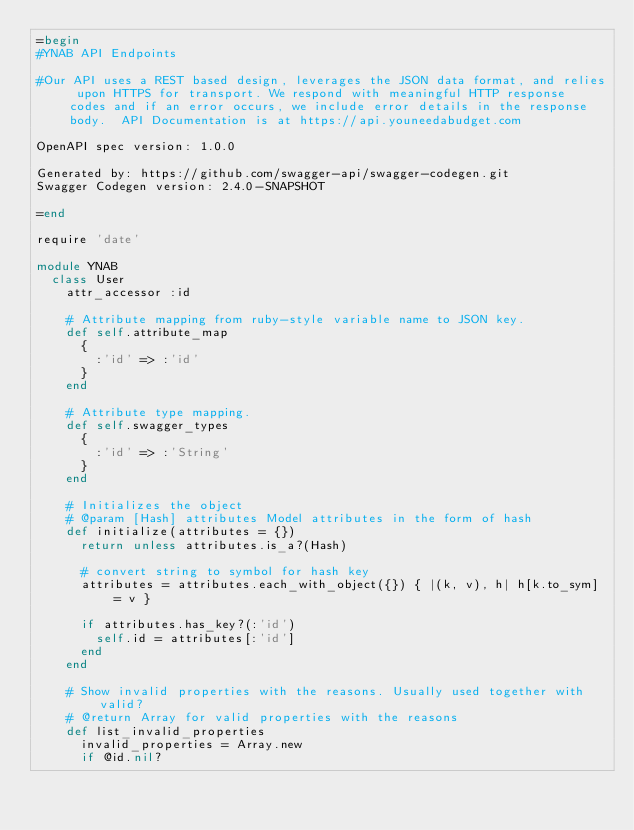Convert code to text. <code><loc_0><loc_0><loc_500><loc_500><_Ruby_>=begin
#YNAB API Endpoints

#Our API uses a REST based design, leverages the JSON data format, and relies upon HTTPS for transport. We respond with meaningful HTTP response codes and if an error occurs, we include error details in the response body.  API Documentation is at https://api.youneedabudget.com

OpenAPI spec version: 1.0.0

Generated by: https://github.com/swagger-api/swagger-codegen.git
Swagger Codegen version: 2.4.0-SNAPSHOT

=end

require 'date'

module YNAB
  class User
    attr_accessor :id

    # Attribute mapping from ruby-style variable name to JSON key.
    def self.attribute_map
      {
        :'id' => :'id'
      }
    end

    # Attribute type mapping.
    def self.swagger_types
      {
        :'id' => :'String'
      }
    end

    # Initializes the object
    # @param [Hash] attributes Model attributes in the form of hash
    def initialize(attributes = {})
      return unless attributes.is_a?(Hash)

      # convert string to symbol for hash key
      attributes = attributes.each_with_object({}) { |(k, v), h| h[k.to_sym] = v }

      if attributes.has_key?(:'id')
        self.id = attributes[:'id']
      end
    end

    # Show invalid properties with the reasons. Usually used together with valid?
    # @return Array for valid properties with the reasons
    def list_invalid_properties
      invalid_properties = Array.new
      if @id.nil?</code> 